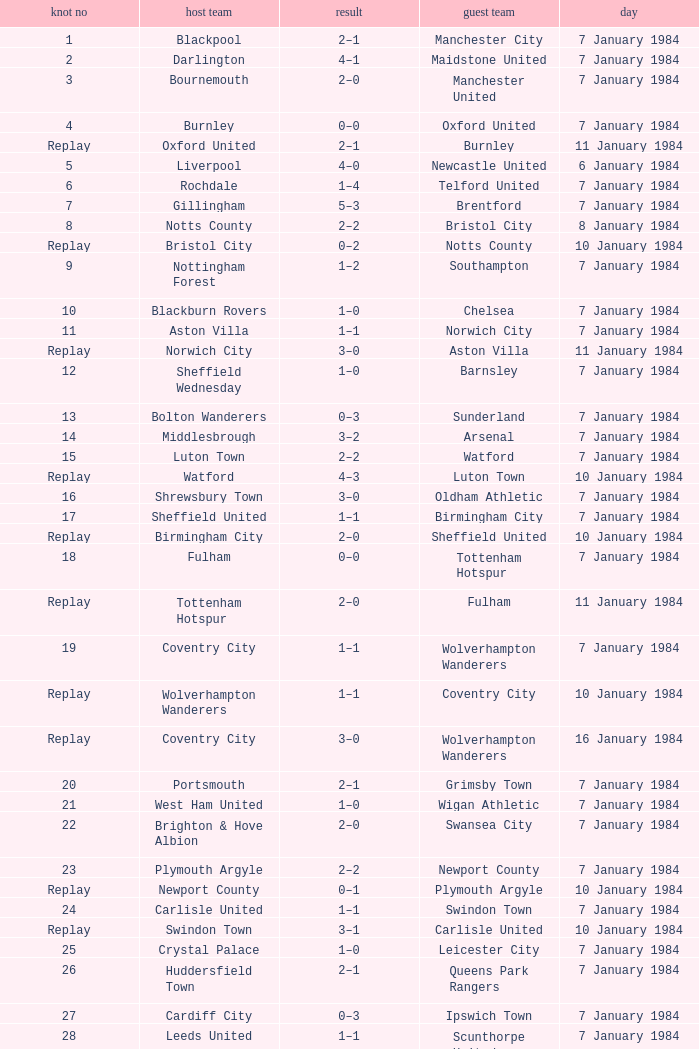Who was the away team against the home team Sheffield United? Birmingham City. 